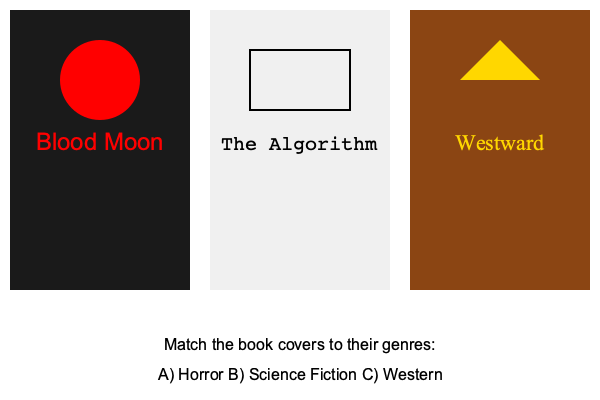As a fellow writer familiar with various literary genres, can you correctly match the book cover designs to their respective genres? To match the book cover designs to their respective genres, we need to analyze the visual elements and typography of each cover:

1. Left cover (Blood Moon):
   - Dark background (black)
   - Red text and a red circle (possibly representing a moon)
   - Ominous title and color scheme
   This cover suggests a horror genre, as it evokes a sense of dread and uses common horror visual tropes.

2. Middle cover (The Algorithm):
   - Light background (white/gray)
   - Simple, sans-serif font
   - Geometric shape (rectangle)
   - Title referencing technology
   These elements are often associated with science fiction, emphasizing clean designs and technological themes.

3. Right cover (Westward):
   - Brown background (earthy tone)
   - Gold text and a triangle shape (possibly representing a mountain or tent)
   - Title suggesting direction or movement
   These visual cues are typical of Western genre covers, evoking images of the frontier and adventure.

Therefore, the correct matching is:
Left (Blood Moon) - A) Horror
Middle (The Algorithm) - B) Science Fiction
Right (Westward) - C) Western
Answer: A-Horror, B-Science Fiction, C-Western 